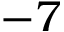Convert formula to latex. <formula><loc_0><loc_0><loc_500><loc_500>- 7</formula> 